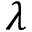<formula> <loc_0><loc_0><loc_500><loc_500>\lambda</formula> 